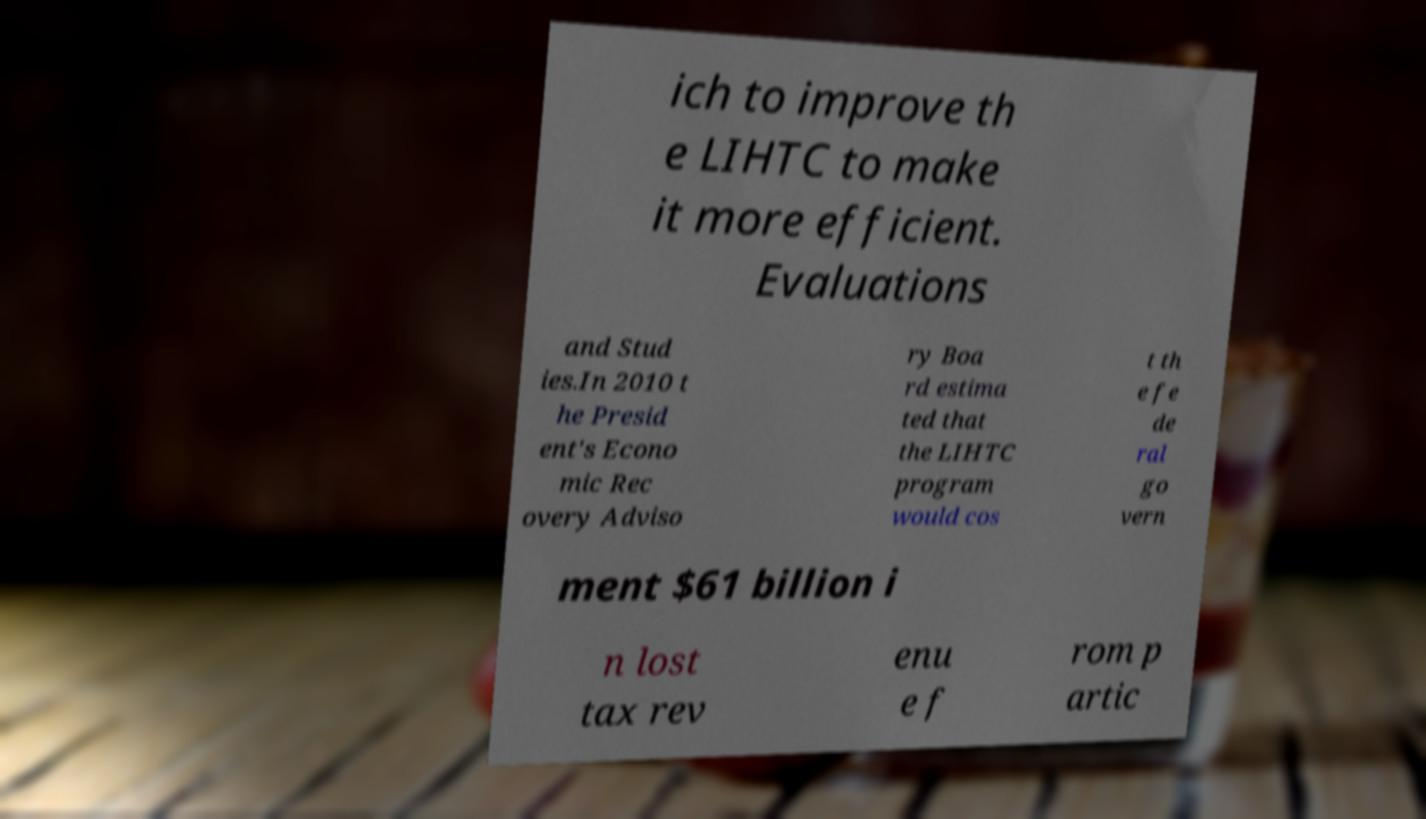For documentation purposes, I need the text within this image transcribed. Could you provide that? ich to improve th e LIHTC to make it more efficient. Evaluations and Stud ies.In 2010 t he Presid ent's Econo mic Rec overy Adviso ry Boa rd estima ted that the LIHTC program would cos t th e fe de ral go vern ment $61 billion i n lost tax rev enu e f rom p artic 